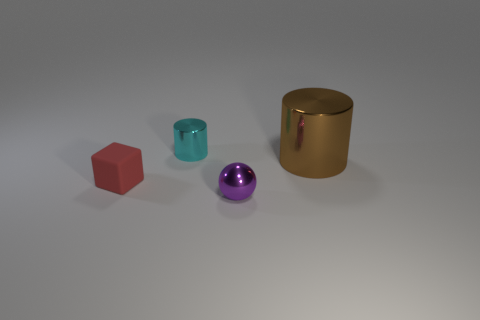There is a shiny cylinder to the right of the cylinder that is to the left of the tiny metallic thing in front of the tiny red block; how big is it?
Give a very brief answer. Large. What is the material of the purple thing that is the same size as the cyan metal cylinder?
Your answer should be compact. Metal. Is there a cyan object of the same size as the rubber block?
Your response must be concise. Yes. Is the large brown object the same shape as the small cyan metal object?
Give a very brief answer. Yes. There is a metal thing in front of the cylinder in front of the tiny cylinder; is there a tiny purple ball behind it?
Your answer should be compact. No. What number of other objects are there of the same color as the large shiny object?
Ensure brevity in your answer.  0. Is the size of the thing that is on the left side of the small cyan shiny cylinder the same as the metal cylinder to the right of the purple shiny object?
Make the answer very short. No. Is the number of big things to the left of the red matte block the same as the number of small rubber objects in front of the tiny purple ball?
Ensure brevity in your answer.  Yes. Are there any other things that are made of the same material as the red block?
Ensure brevity in your answer.  No. Do the red rubber thing and the metal cylinder that is to the left of the large brown thing have the same size?
Provide a short and direct response. Yes. 